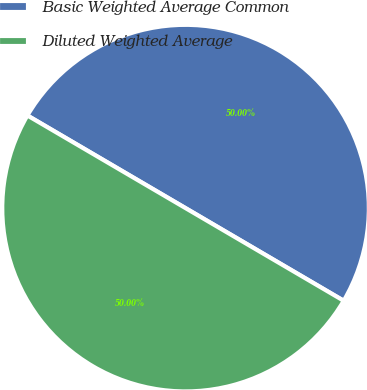<chart> <loc_0><loc_0><loc_500><loc_500><pie_chart><fcel>Basic Weighted Average Common<fcel>Diluted Weighted Average<nl><fcel>50.0%<fcel>50.0%<nl></chart> 